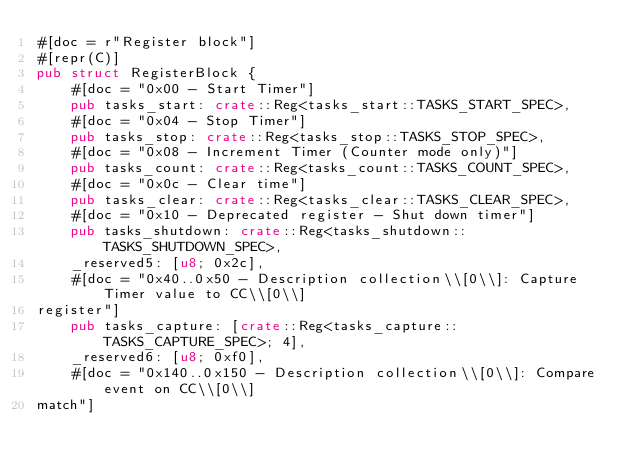Convert code to text. <code><loc_0><loc_0><loc_500><loc_500><_Rust_>#[doc = r"Register block"]
#[repr(C)]
pub struct RegisterBlock {
    #[doc = "0x00 - Start Timer"]
    pub tasks_start: crate::Reg<tasks_start::TASKS_START_SPEC>,
    #[doc = "0x04 - Stop Timer"]
    pub tasks_stop: crate::Reg<tasks_stop::TASKS_STOP_SPEC>,
    #[doc = "0x08 - Increment Timer (Counter mode only)"]
    pub tasks_count: crate::Reg<tasks_count::TASKS_COUNT_SPEC>,
    #[doc = "0x0c - Clear time"]
    pub tasks_clear: crate::Reg<tasks_clear::TASKS_CLEAR_SPEC>,
    #[doc = "0x10 - Deprecated register - Shut down timer"]
    pub tasks_shutdown: crate::Reg<tasks_shutdown::TASKS_SHUTDOWN_SPEC>,
    _reserved5: [u8; 0x2c],
    #[doc = "0x40..0x50 - Description collection\\[0\\]: Capture Timer value to CC\\[0\\]
register"]
    pub tasks_capture: [crate::Reg<tasks_capture::TASKS_CAPTURE_SPEC>; 4],
    _reserved6: [u8; 0xf0],
    #[doc = "0x140..0x150 - Description collection\\[0\\]: Compare event on CC\\[0\\]
match"]</code> 